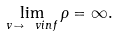Convert formula to latex. <formula><loc_0><loc_0><loc_500><loc_500>\lim _ { v \to \ v i n f } \rho = \infty .</formula> 